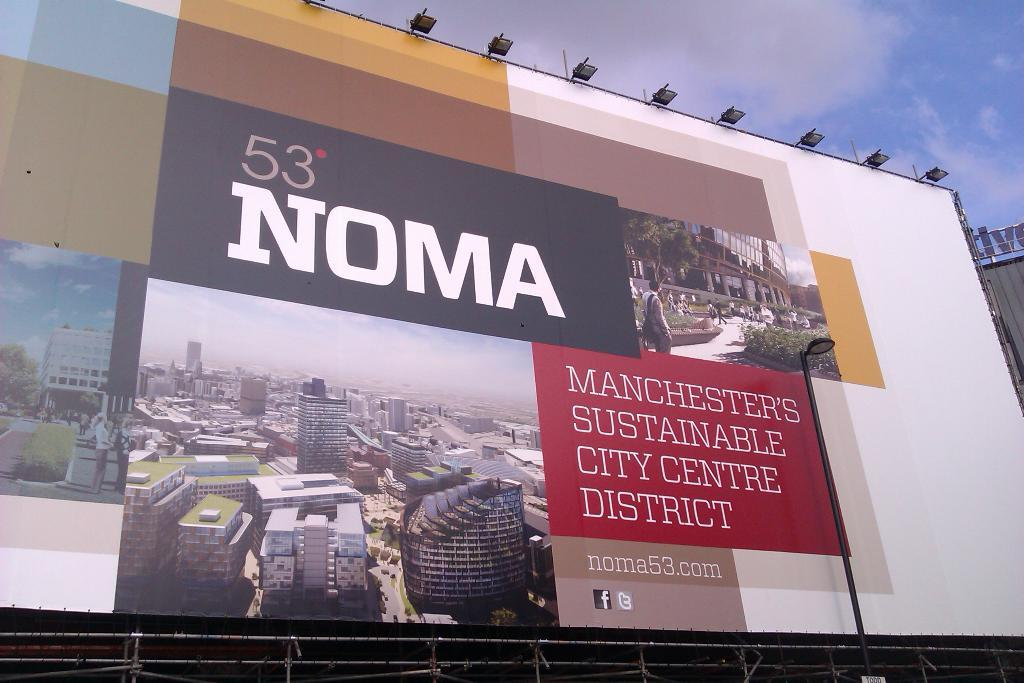<image>
Give a short and clear explanation of the subsequent image. A poster displaying Manchester's sustainable city centre district 